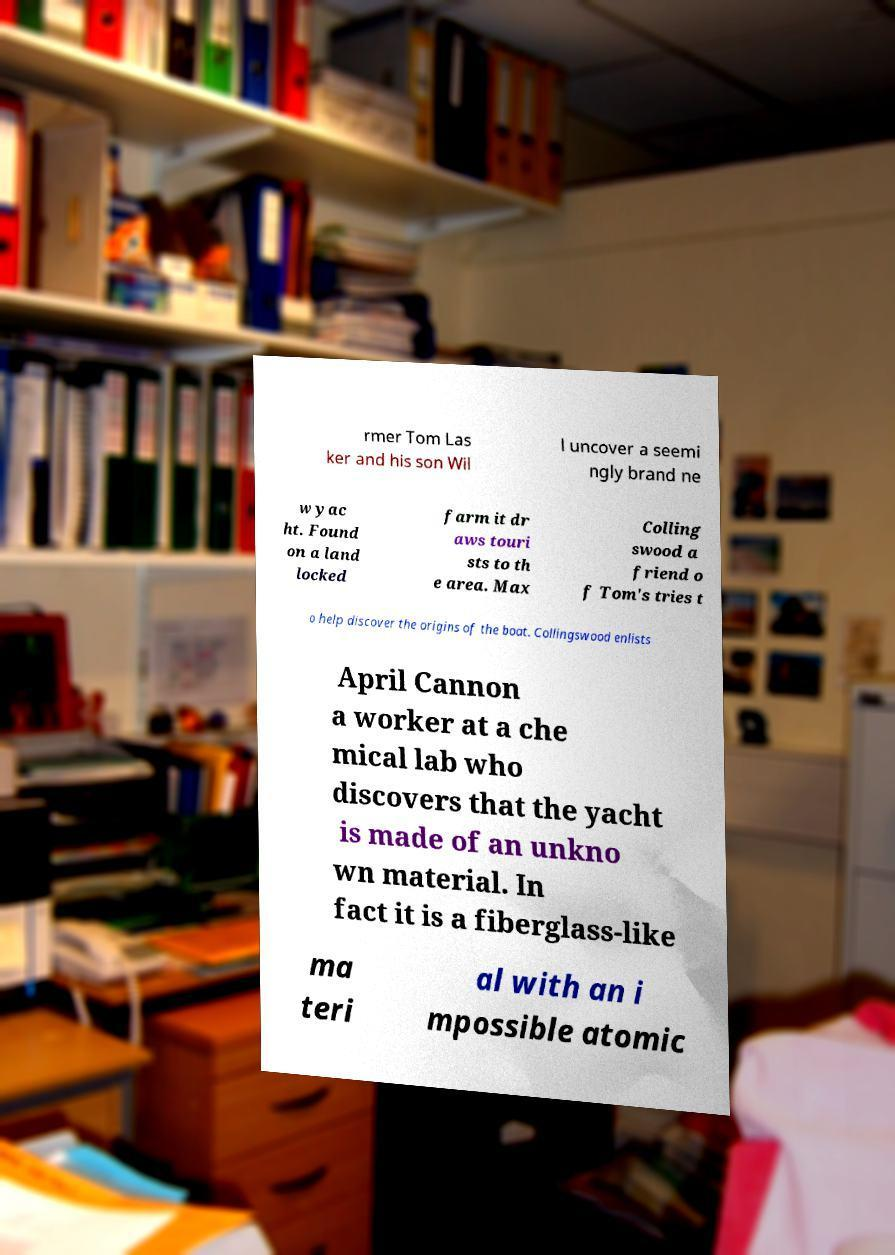Can you read and provide the text displayed in the image?This photo seems to have some interesting text. Can you extract and type it out for me? rmer Tom Las ker and his son Wil l uncover a seemi ngly brand ne w yac ht. Found on a land locked farm it dr aws touri sts to th e area. Max Colling swood a friend o f Tom's tries t o help discover the origins of the boat. Collingswood enlists April Cannon a worker at a che mical lab who discovers that the yacht is made of an unkno wn material. In fact it is a fiberglass-like ma teri al with an i mpossible atomic 